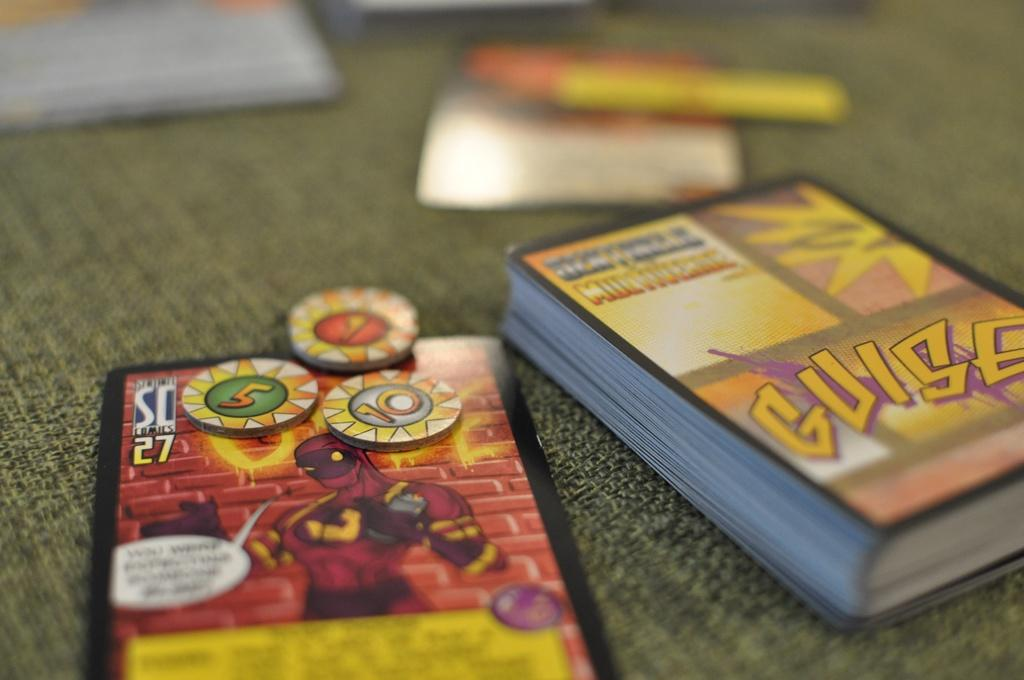<image>
Present a compact description of the photo's key features. A deck of cards with the name Guise are on a fabric surface. 